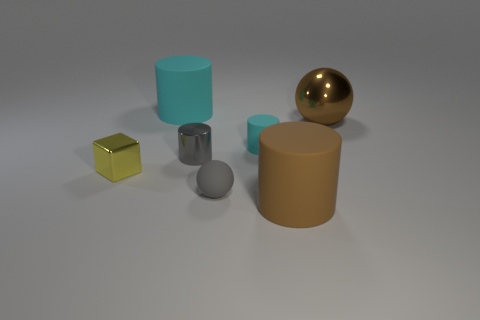Add 2 big purple rubber cylinders. How many objects exist? 9 Subtract all blocks. How many objects are left? 6 Add 6 gray balls. How many gray balls are left? 7 Add 6 matte cylinders. How many matte cylinders exist? 9 Subtract 0 purple cubes. How many objects are left? 7 Subtract all cyan rubber objects. Subtract all small purple blocks. How many objects are left? 5 